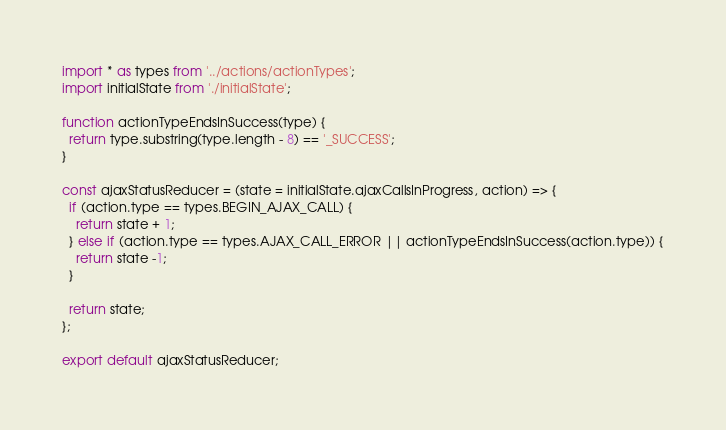<code> <loc_0><loc_0><loc_500><loc_500><_JavaScript_>import * as types from '../actions/actionTypes';
import initialState from './initialState';

function actionTypeEndsInSuccess(type) {
  return type.substring(type.length - 8) == '_SUCCESS';
}

const ajaxStatusReducer = (state = initialState.ajaxCallsInProgress, action) => {
  if (action.type == types.BEGIN_AJAX_CALL) {
    return state + 1;
  } else if (action.type == types.AJAX_CALL_ERROR || actionTypeEndsInSuccess(action.type)) {
    return state -1;
  }

  return state;
};

export default ajaxStatusReducer;
</code> 